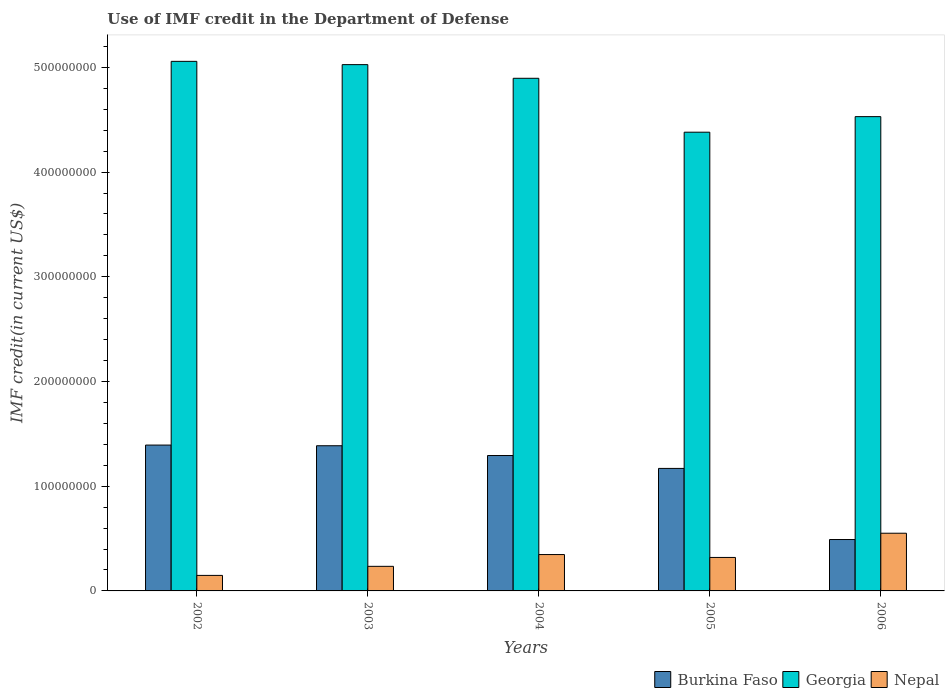Are the number of bars per tick equal to the number of legend labels?
Your answer should be very brief. Yes. How many bars are there on the 2nd tick from the right?
Your response must be concise. 3. In how many cases, is the number of bars for a given year not equal to the number of legend labels?
Offer a terse response. 0. What is the IMF credit in the Department of Defense in Burkina Faso in 2004?
Make the answer very short. 1.29e+08. Across all years, what is the maximum IMF credit in the Department of Defense in Burkina Faso?
Keep it short and to the point. 1.39e+08. Across all years, what is the minimum IMF credit in the Department of Defense in Georgia?
Offer a terse response. 4.38e+08. In which year was the IMF credit in the Department of Defense in Burkina Faso maximum?
Offer a terse response. 2002. In which year was the IMF credit in the Department of Defense in Nepal minimum?
Keep it short and to the point. 2002. What is the total IMF credit in the Department of Defense in Burkina Faso in the graph?
Keep it short and to the point. 5.73e+08. What is the difference between the IMF credit in the Department of Defense in Georgia in 2004 and that in 2006?
Provide a short and direct response. 3.66e+07. What is the difference between the IMF credit in the Department of Defense in Burkina Faso in 2005 and the IMF credit in the Department of Defense in Georgia in 2004?
Your answer should be compact. -3.73e+08. What is the average IMF credit in the Department of Defense in Georgia per year?
Provide a succinct answer. 4.78e+08. In the year 2005, what is the difference between the IMF credit in the Department of Defense in Nepal and IMF credit in the Department of Defense in Georgia?
Ensure brevity in your answer.  -4.06e+08. What is the ratio of the IMF credit in the Department of Defense in Nepal in 2002 to that in 2006?
Offer a terse response. 0.27. What is the difference between the highest and the second highest IMF credit in the Department of Defense in Burkina Faso?
Keep it short and to the point. 6.52e+05. What is the difference between the highest and the lowest IMF credit in the Department of Defense in Burkina Faso?
Offer a terse response. 9.02e+07. Is the sum of the IMF credit in the Department of Defense in Georgia in 2003 and 2006 greater than the maximum IMF credit in the Department of Defense in Nepal across all years?
Give a very brief answer. Yes. What does the 1st bar from the left in 2002 represents?
Your answer should be very brief. Burkina Faso. What does the 1st bar from the right in 2002 represents?
Offer a very short reply. Nepal. Is it the case that in every year, the sum of the IMF credit in the Department of Defense in Burkina Faso and IMF credit in the Department of Defense in Nepal is greater than the IMF credit in the Department of Defense in Georgia?
Provide a short and direct response. No. How many bars are there?
Provide a succinct answer. 15. What is the difference between two consecutive major ticks on the Y-axis?
Keep it short and to the point. 1.00e+08. Does the graph contain grids?
Offer a terse response. No. How are the legend labels stacked?
Ensure brevity in your answer.  Horizontal. What is the title of the graph?
Your answer should be very brief. Use of IMF credit in the Department of Defense. What is the label or title of the X-axis?
Your answer should be very brief. Years. What is the label or title of the Y-axis?
Your answer should be very brief. IMF credit(in current US$). What is the IMF credit(in current US$) in Burkina Faso in 2002?
Offer a very short reply. 1.39e+08. What is the IMF credit(in current US$) in Georgia in 2002?
Offer a very short reply. 5.06e+08. What is the IMF credit(in current US$) in Nepal in 2002?
Provide a short and direct response. 1.48e+07. What is the IMF credit(in current US$) of Burkina Faso in 2003?
Give a very brief answer. 1.39e+08. What is the IMF credit(in current US$) in Georgia in 2003?
Give a very brief answer. 5.03e+08. What is the IMF credit(in current US$) of Nepal in 2003?
Offer a very short reply. 2.35e+07. What is the IMF credit(in current US$) of Burkina Faso in 2004?
Your response must be concise. 1.29e+08. What is the IMF credit(in current US$) in Georgia in 2004?
Provide a short and direct response. 4.90e+08. What is the IMF credit(in current US$) of Nepal in 2004?
Ensure brevity in your answer.  3.47e+07. What is the IMF credit(in current US$) of Burkina Faso in 2005?
Provide a succinct answer. 1.17e+08. What is the IMF credit(in current US$) of Georgia in 2005?
Offer a terse response. 4.38e+08. What is the IMF credit(in current US$) in Nepal in 2005?
Give a very brief answer. 3.20e+07. What is the IMF credit(in current US$) in Burkina Faso in 2006?
Give a very brief answer. 4.91e+07. What is the IMF credit(in current US$) in Georgia in 2006?
Keep it short and to the point. 4.53e+08. What is the IMF credit(in current US$) in Nepal in 2006?
Your answer should be compact. 5.51e+07. Across all years, what is the maximum IMF credit(in current US$) in Burkina Faso?
Make the answer very short. 1.39e+08. Across all years, what is the maximum IMF credit(in current US$) in Georgia?
Ensure brevity in your answer.  5.06e+08. Across all years, what is the maximum IMF credit(in current US$) of Nepal?
Your answer should be compact. 5.51e+07. Across all years, what is the minimum IMF credit(in current US$) of Burkina Faso?
Make the answer very short. 4.91e+07. Across all years, what is the minimum IMF credit(in current US$) in Georgia?
Provide a short and direct response. 4.38e+08. Across all years, what is the minimum IMF credit(in current US$) in Nepal?
Your answer should be very brief. 1.48e+07. What is the total IMF credit(in current US$) in Burkina Faso in the graph?
Your response must be concise. 5.73e+08. What is the total IMF credit(in current US$) of Georgia in the graph?
Your answer should be compact. 2.39e+09. What is the total IMF credit(in current US$) in Nepal in the graph?
Your answer should be very brief. 1.60e+08. What is the difference between the IMF credit(in current US$) of Burkina Faso in 2002 and that in 2003?
Keep it short and to the point. 6.52e+05. What is the difference between the IMF credit(in current US$) of Georgia in 2002 and that in 2003?
Ensure brevity in your answer.  3.13e+06. What is the difference between the IMF credit(in current US$) of Nepal in 2002 and that in 2003?
Ensure brevity in your answer.  -8.65e+06. What is the difference between the IMF credit(in current US$) in Burkina Faso in 2002 and that in 2004?
Offer a very short reply. 9.99e+06. What is the difference between the IMF credit(in current US$) in Georgia in 2002 and that in 2004?
Ensure brevity in your answer.  1.62e+07. What is the difference between the IMF credit(in current US$) in Nepal in 2002 and that in 2004?
Make the answer very short. -1.99e+07. What is the difference between the IMF credit(in current US$) of Burkina Faso in 2002 and that in 2005?
Your response must be concise. 2.23e+07. What is the difference between the IMF credit(in current US$) in Georgia in 2002 and that in 2005?
Keep it short and to the point. 6.76e+07. What is the difference between the IMF credit(in current US$) of Nepal in 2002 and that in 2005?
Ensure brevity in your answer.  -1.71e+07. What is the difference between the IMF credit(in current US$) of Burkina Faso in 2002 and that in 2006?
Your answer should be compact. 9.02e+07. What is the difference between the IMF credit(in current US$) in Georgia in 2002 and that in 2006?
Your response must be concise. 5.28e+07. What is the difference between the IMF credit(in current US$) of Nepal in 2002 and that in 2006?
Your response must be concise. -4.03e+07. What is the difference between the IMF credit(in current US$) in Burkina Faso in 2003 and that in 2004?
Your response must be concise. 9.34e+06. What is the difference between the IMF credit(in current US$) in Georgia in 2003 and that in 2004?
Provide a succinct answer. 1.30e+07. What is the difference between the IMF credit(in current US$) of Nepal in 2003 and that in 2004?
Your answer should be compact. -1.13e+07. What is the difference between the IMF credit(in current US$) of Burkina Faso in 2003 and that in 2005?
Offer a terse response. 2.17e+07. What is the difference between the IMF credit(in current US$) in Georgia in 2003 and that in 2005?
Provide a succinct answer. 6.45e+07. What is the difference between the IMF credit(in current US$) of Nepal in 2003 and that in 2005?
Provide a succinct answer. -8.50e+06. What is the difference between the IMF credit(in current US$) of Burkina Faso in 2003 and that in 2006?
Keep it short and to the point. 8.95e+07. What is the difference between the IMF credit(in current US$) in Georgia in 2003 and that in 2006?
Your answer should be very brief. 4.97e+07. What is the difference between the IMF credit(in current US$) in Nepal in 2003 and that in 2006?
Your answer should be very brief. -3.16e+07. What is the difference between the IMF credit(in current US$) of Burkina Faso in 2004 and that in 2005?
Your response must be concise. 1.23e+07. What is the difference between the IMF credit(in current US$) of Georgia in 2004 and that in 2005?
Your response must be concise. 5.15e+07. What is the difference between the IMF credit(in current US$) of Nepal in 2004 and that in 2005?
Give a very brief answer. 2.77e+06. What is the difference between the IMF credit(in current US$) in Burkina Faso in 2004 and that in 2006?
Make the answer very short. 8.02e+07. What is the difference between the IMF credit(in current US$) of Georgia in 2004 and that in 2006?
Your answer should be compact. 3.66e+07. What is the difference between the IMF credit(in current US$) of Nepal in 2004 and that in 2006?
Your answer should be compact. -2.04e+07. What is the difference between the IMF credit(in current US$) of Burkina Faso in 2005 and that in 2006?
Offer a very short reply. 6.79e+07. What is the difference between the IMF credit(in current US$) of Georgia in 2005 and that in 2006?
Make the answer very short. -1.49e+07. What is the difference between the IMF credit(in current US$) of Nepal in 2005 and that in 2006?
Your answer should be very brief. -2.31e+07. What is the difference between the IMF credit(in current US$) in Burkina Faso in 2002 and the IMF credit(in current US$) in Georgia in 2003?
Your answer should be very brief. -3.63e+08. What is the difference between the IMF credit(in current US$) of Burkina Faso in 2002 and the IMF credit(in current US$) of Nepal in 2003?
Keep it short and to the point. 1.16e+08. What is the difference between the IMF credit(in current US$) in Georgia in 2002 and the IMF credit(in current US$) in Nepal in 2003?
Your answer should be very brief. 4.82e+08. What is the difference between the IMF credit(in current US$) in Burkina Faso in 2002 and the IMF credit(in current US$) in Georgia in 2004?
Provide a succinct answer. -3.50e+08. What is the difference between the IMF credit(in current US$) in Burkina Faso in 2002 and the IMF credit(in current US$) in Nepal in 2004?
Your response must be concise. 1.05e+08. What is the difference between the IMF credit(in current US$) of Georgia in 2002 and the IMF credit(in current US$) of Nepal in 2004?
Give a very brief answer. 4.71e+08. What is the difference between the IMF credit(in current US$) in Burkina Faso in 2002 and the IMF credit(in current US$) in Georgia in 2005?
Offer a very short reply. -2.99e+08. What is the difference between the IMF credit(in current US$) of Burkina Faso in 2002 and the IMF credit(in current US$) of Nepal in 2005?
Keep it short and to the point. 1.07e+08. What is the difference between the IMF credit(in current US$) of Georgia in 2002 and the IMF credit(in current US$) of Nepal in 2005?
Your response must be concise. 4.74e+08. What is the difference between the IMF credit(in current US$) of Burkina Faso in 2002 and the IMF credit(in current US$) of Georgia in 2006?
Your answer should be very brief. -3.14e+08. What is the difference between the IMF credit(in current US$) of Burkina Faso in 2002 and the IMF credit(in current US$) of Nepal in 2006?
Make the answer very short. 8.42e+07. What is the difference between the IMF credit(in current US$) of Georgia in 2002 and the IMF credit(in current US$) of Nepal in 2006?
Offer a very short reply. 4.51e+08. What is the difference between the IMF credit(in current US$) of Burkina Faso in 2003 and the IMF credit(in current US$) of Georgia in 2004?
Give a very brief answer. -3.51e+08. What is the difference between the IMF credit(in current US$) of Burkina Faso in 2003 and the IMF credit(in current US$) of Nepal in 2004?
Your response must be concise. 1.04e+08. What is the difference between the IMF credit(in current US$) in Georgia in 2003 and the IMF credit(in current US$) in Nepal in 2004?
Ensure brevity in your answer.  4.68e+08. What is the difference between the IMF credit(in current US$) of Burkina Faso in 2003 and the IMF credit(in current US$) of Georgia in 2005?
Ensure brevity in your answer.  -2.99e+08. What is the difference between the IMF credit(in current US$) of Burkina Faso in 2003 and the IMF credit(in current US$) of Nepal in 2005?
Keep it short and to the point. 1.07e+08. What is the difference between the IMF credit(in current US$) in Georgia in 2003 and the IMF credit(in current US$) in Nepal in 2005?
Make the answer very short. 4.71e+08. What is the difference between the IMF credit(in current US$) of Burkina Faso in 2003 and the IMF credit(in current US$) of Georgia in 2006?
Your answer should be compact. -3.14e+08. What is the difference between the IMF credit(in current US$) of Burkina Faso in 2003 and the IMF credit(in current US$) of Nepal in 2006?
Offer a very short reply. 8.35e+07. What is the difference between the IMF credit(in current US$) of Georgia in 2003 and the IMF credit(in current US$) of Nepal in 2006?
Your answer should be very brief. 4.47e+08. What is the difference between the IMF credit(in current US$) of Burkina Faso in 2004 and the IMF credit(in current US$) of Georgia in 2005?
Offer a terse response. -3.09e+08. What is the difference between the IMF credit(in current US$) of Burkina Faso in 2004 and the IMF credit(in current US$) of Nepal in 2005?
Make the answer very short. 9.73e+07. What is the difference between the IMF credit(in current US$) of Georgia in 2004 and the IMF credit(in current US$) of Nepal in 2005?
Provide a succinct answer. 4.58e+08. What is the difference between the IMF credit(in current US$) in Burkina Faso in 2004 and the IMF credit(in current US$) in Georgia in 2006?
Provide a succinct answer. -3.24e+08. What is the difference between the IMF credit(in current US$) of Burkina Faso in 2004 and the IMF credit(in current US$) of Nepal in 2006?
Give a very brief answer. 7.42e+07. What is the difference between the IMF credit(in current US$) of Georgia in 2004 and the IMF credit(in current US$) of Nepal in 2006?
Give a very brief answer. 4.34e+08. What is the difference between the IMF credit(in current US$) in Burkina Faso in 2005 and the IMF credit(in current US$) in Georgia in 2006?
Your response must be concise. -3.36e+08. What is the difference between the IMF credit(in current US$) in Burkina Faso in 2005 and the IMF credit(in current US$) in Nepal in 2006?
Your response must be concise. 6.19e+07. What is the difference between the IMF credit(in current US$) of Georgia in 2005 and the IMF credit(in current US$) of Nepal in 2006?
Make the answer very short. 3.83e+08. What is the average IMF credit(in current US$) of Burkina Faso per year?
Your answer should be compact. 1.15e+08. What is the average IMF credit(in current US$) of Georgia per year?
Provide a short and direct response. 4.78e+08. What is the average IMF credit(in current US$) in Nepal per year?
Provide a short and direct response. 3.20e+07. In the year 2002, what is the difference between the IMF credit(in current US$) in Burkina Faso and IMF credit(in current US$) in Georgia?
Provide a short and direct response. -3.66e+08. In the year 2002, what is the difference between the IMF credit(in current US$) of Burkina Faso and IMF credit(in current US$) of Nepal?
Make the answer very short. 1.24e+08. In the year 2002, what is the difference between the IMF credit(in current US$) of Georgia and IMF credit(in current US$) of Nepal?
Offer a terse response. 4.91e+08. In the year 2003, what is the difference between the IMF credit(in current US$) in Burkina Faso and IMF credit(in current US$) in Georgia?
Your response must be concise. -3.64e+08. In the year 2003, what is the difference between the IMF credit(in current US$) in Burkina Faso and IMF credit(in current US$) in Nepal?
Make the answer very short. 1.15e+08. In the year 2003, what is the difference between the IMF credit(in current US$) of Georgia and IMF credit(in current US$) of Nepal?
Make the answer very short. 4.79e+08. In the year 2004, what is the difference between the IMF credit(in current US$) of Burkina Faso and IMF credit(in current US$) of Georgia?
Offer a terse response. -3.60e+08. In the year 2004, what is the difference between the IMF credit(in current US$) of Burkina Faso and IMF credit(in current US$) of Nepal?
Provide a succinct answer. 9.46e+07. In the year 2004, what is the difference between the IMF credit(in current US$) in Georgia and IMF credit(in current US$) in Nepal?
Provide a short and direct response. 4.55e+08. In the year 2005, what is the difference between the IMF credit(in current US$) of Burkina Faso and IMF credit(in current US$) of Georgia?
Your response must be concise. -3.21e+08. In the year 2005, what is the difference between the IMF credit(in current US$) of Burkina Faso and IMF credit(in current US$) of Nepal?
Provide a short and direct response. 8.50e+07. In the year 2005, what is the difference between the IMF credit(in current US$) of Georgia and IMF credit(in current US$) of Nepal?
Your response must be concise. 4.06e+08. In the year 2006, what is the difference between the IMF credit(in current US$) in Burkina Faso and IMF credit(in current US$) in Georgia?
Offer a terse response. -4.04e+08. In the year 2006, what is the difference between the IMF credit(in current US$) of Burkina Faso and IMF credit(in current US$) of Nepal?
Your answer should be very brief. -6.01e+06. In the year 2006, what is the difference between the IMF credit(in current US$) of Georgia and IMF credit(in current US$) of Nepal?
Your answer should be compact. 3.98e+08. What is the ratio of the IMF credit(in current US$) in Nepal in 2002 to that in 2003?
Make the answer very short. 0.63. What is the ratio of the IMF credit(in current US$) in Burkina Faso in 2002 to that in 2004?
Offer a very short reply. 1.08. What is the ratio of the IMF credit(in current US$) in Georgia in 2002 to that in 2004?
Provide a succinct answer. 1.03. What is the ratio of the IMF credit(in current US$) of Nepal in 2002 to that in 2004?
Your answer should be very brief. 0.43. What is the ratio of the IMF credit(in current US$) of Burkina Faso in 2002 to that in 2005?
Make the answer very short. 1.19. What is the ratio of the IMF credit(in current US$) of Georgia in 2002 to that in 2005?
Make the answer very short. 1.15. What is the ratio of the IMF credit(in current US$) of Nepal in 2002 to that in 2005?
Your answer should be compact. 0.46. What is the ratio of the IMF credit(in current US$) in Burkina Faso in 2002 to that in 2006?
Offer a terse response. 2.84. What is the ratio of the IMF credit(in current US$) of Georgia in 2002 to that in 2006?
Provide a short and direct response. 1.12. What is the ratio of the IMF credit(in current US$) in Nepal in 2002 to that in 2006?
Offer a terse response. 0.27. What is the ratio of the IMF credit(in current US$) of Burkina Faso in 2003 to that in 2004?
Make the answer very short. 1.07. What is the ratio of the IMF credit(in current US$) of Georgia in 2003 to that in 2004?
Give a very brief answer. 1.03. What is the ratio of the IMF credit(in current US$) in Nepal in 2003 to that in 2004?
Provide a short and direct response. 0.68. What is the ratio of the IMF credit(in current US$) of Burkina Faso in 2003 to that in 2005?
Keep it short and to the point. 1.19. What is the ratio of the IMF credit(in current US$) of Georgia in 2003 to that in 2005?
Ensure brevity in your answer.  1.15. What is the ratio of the IMF credit(in current US$) in Nepal in 2003 to that in 2005?
Make the answer very short. 0.73. What is the ratio of the IMF credit(in current US$) in Burkina Faso in 2003 to that in 2006?
Offer a terse response. 2.82. What is the ratio of the IMF credit(in current US$) in Georgia in 2003 to that in 2006?
Your response must be concise. 1.11. What is the ratio of the IMF credit(in current US$) of Nepal in 2003 to that in 2006?
Ensure brevity in your answer.  0.43. What is the ratio of the IMF credit(in current US$) of Burkina Faso in 2004 to that in 2005?
Your answer should be compact. 1.11. What is the ratio of the IMF credit(in current US$) of Georgia in 2004 to that in 2005?
Make the answer very short. 1.12. What is the ratio of the IMF credit(in current US$) of Nepal in 2004 to that in 2005?
Provide a short and direct response. 1.09. What is the ratio of the IMF credit(in current US$) in Burkina Faso in 2004 to that in 2006?
Give a very brief answer. 2.63. What is the ratio of the IMF credit(in current US$) of Georgia in 2004 to that in 2006?
Offer a very short reply. 1.08. What is the ratio of the IMF credit(in current US$) in Nepal in 2004 to that in 2006?
Provide a short and direct response. 0.63. What is the ratio of the IMF credit(in current US$) of Burkina Faso in 2005 to that in 2006?
Provide a short and direct response. 2.38. What is the ratio of the IMF credit(in current US$) in Georgia in 2005 to that in 2006?
Provide a succinct answer. 0.97. What is the ratio of the IMF credit(in current US$) in Nepal in 2005 to that in 2006?
Keep it short and to the point. 0.58. What is the difference between the highest and the second highest IMF credit(in current US$) of Burkina Faso?
Offer a terse response. 6.52e+05. What is the difference between the highest and the second highest IMF credit(in current US$) in Georgia?
Offer a terse response. 3.13e+06. What is the difference between the highest and the second highest IMF credit(in current US$) of Nepal?
Your answer should be very brief. 2.04e+07. What is the difference between the highest and the lowest IMF credit(in current US$) of Burkina Faso?
Give a very brief answer. 9.02e+07. What is the difference between the highest and the lowest IMF credit(in current US$) of Georgia?
Ensure brevity in your answer.  6.76e+07. What is the difference between the highest and the lowest IMF credit(in current US$) in Nepal?
Your answer should be very brief. 4.03e+07. 